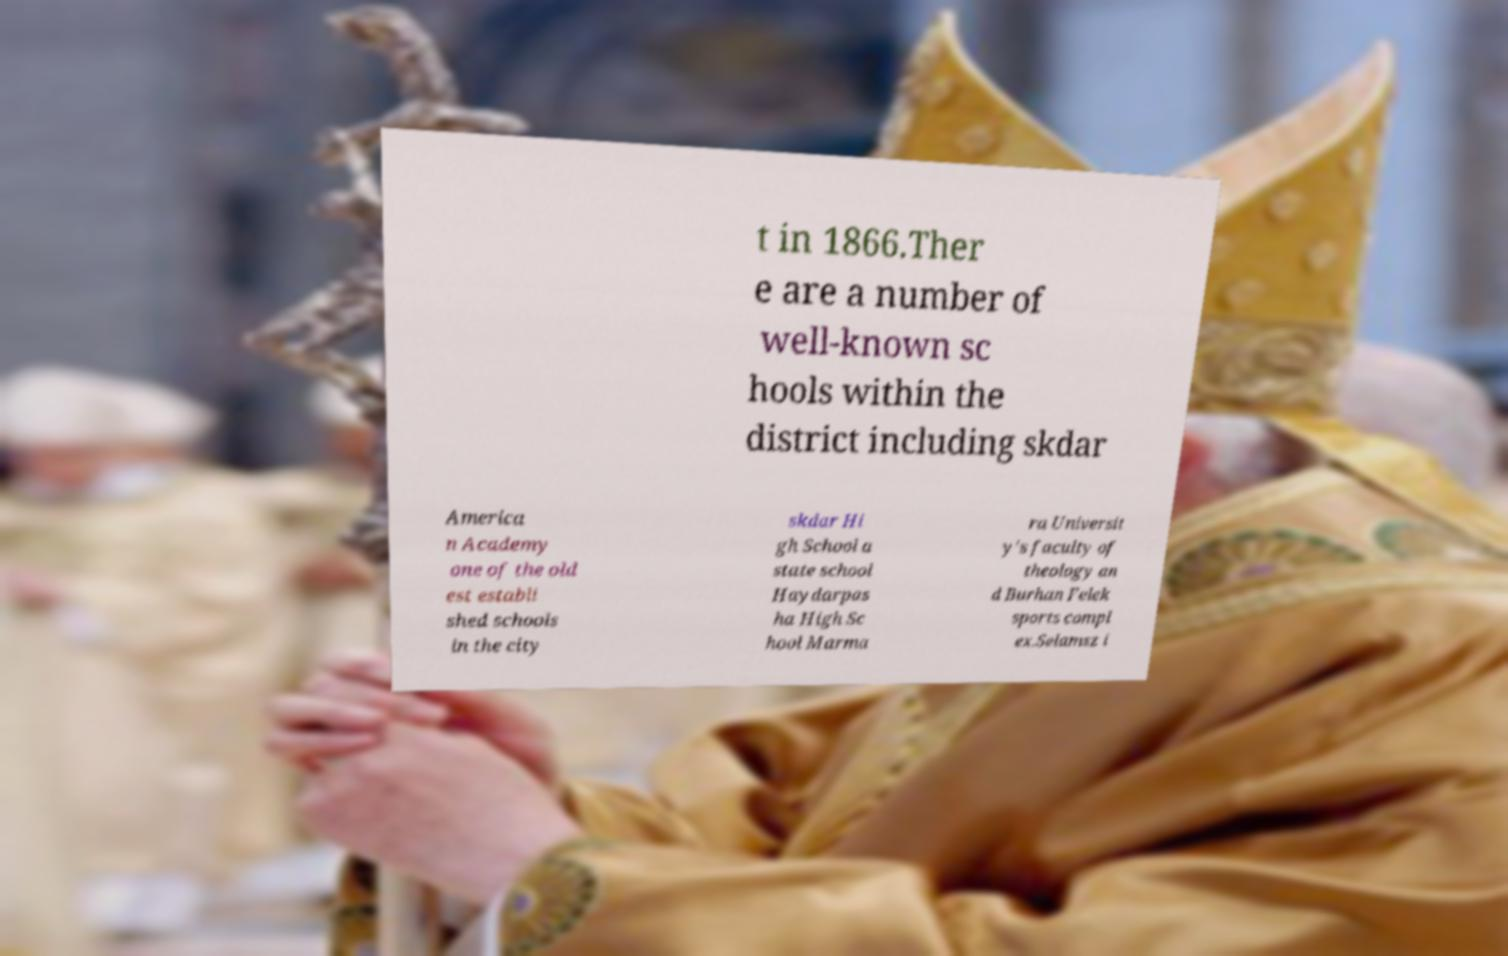Could you assist in decoding the text presented in this image and type it out clearly? t in 1866.Ther e are a number of well-known sc hools within the district including skdar America n Academy one of the old est establi shed schools in the city skdar Hi gh School a state school Haydarpas ha High Sc hool Marma ra Universit y's faculty of theology an d Burhan Felek sports compl ex.Selamsz i 